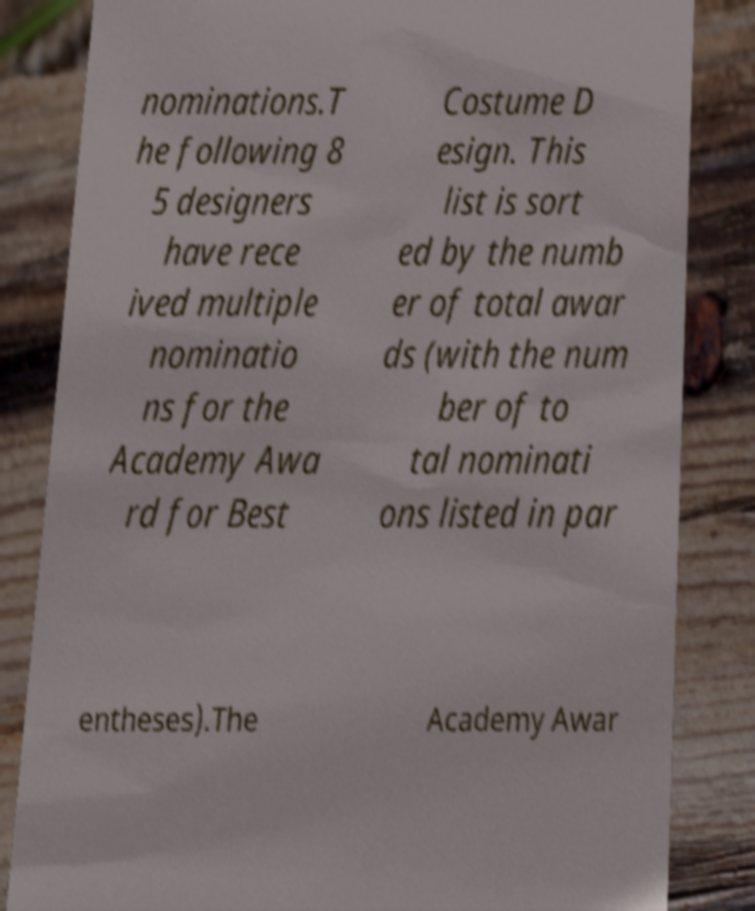There's text embedded in this image that I need extracted. Can you transcribe it verbatim? nominations.T he following 8 5 designers have rece ived multiple nominatio ns for the Academy Awa rd for Best Costume D esign. This list is sort ed by the numb er of total awar ds (with the num ber of to tal nominati ons listed in par entheses).The Academy Awar 